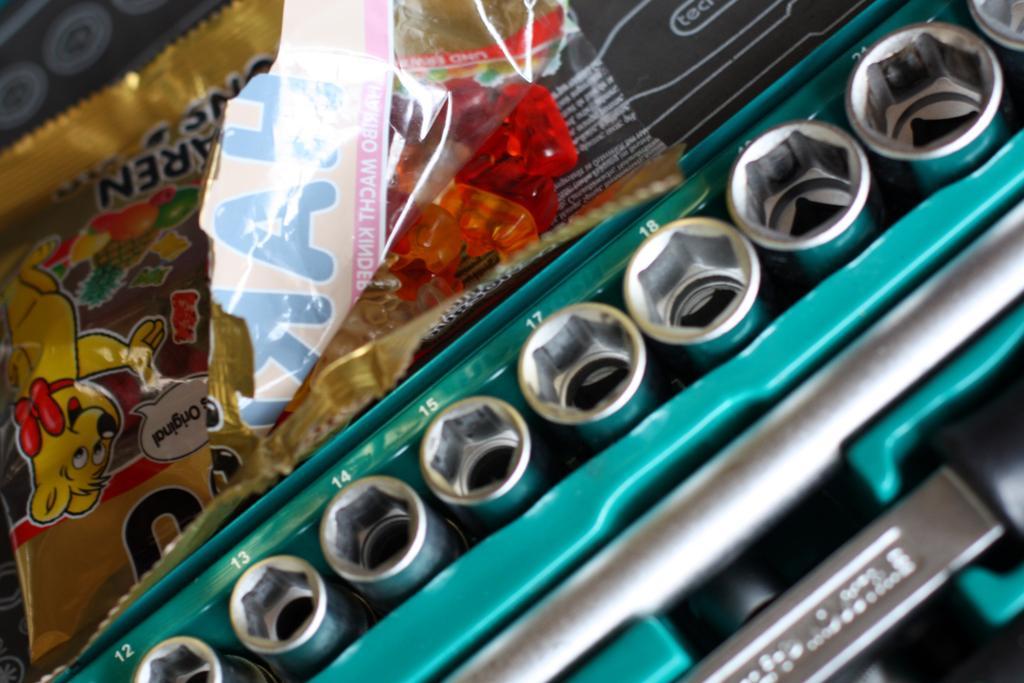How would you summarize this image in a sentence or two? The picture consists of jelly packet, electronic gadget and various other things. 